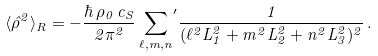<formula> <loc_0><loc_0><loc_500><loc_500>\langle \hat { \rho } ^ { 2 } \rangle _ { R } = - \frac { \hbar { \, } \rho _ { 0 } \, c _ { S } } { 2 \pi ^ { 2 } } \, { \sum _ { \ell , m , n } } ^ { \prime } \frac { 1 } { ( \ell ^ { 2 } L _ { 1 } ^ { 2 } + m ^ { 2 } L _ { 2 } ^ { 2 } + n ^ { 2 } L _ { 3 } ^ { 2 } ) ^ { 2 } } \, .</formula> 